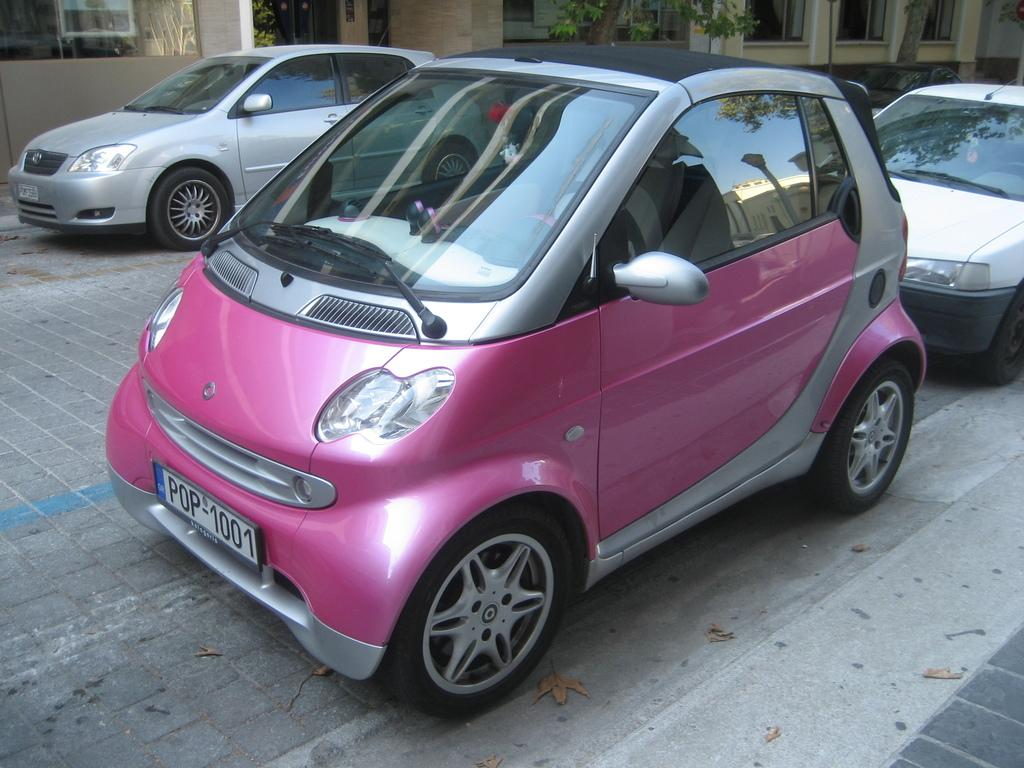How many cars are parked on the land in the image? There are three cars parked on the land in the image. What can be seen behind the cars? There is a complex behind the cars. What feature is prominent on the complex? The complex has plenty of windows. What type of vegetation is in front of the complex? There are two trees in front of the complex. What type of rice is being cooked in the image? There is no rice present in the image; it features three cars parked on the land, a complex behind them, and two trees in front. How many keys are needed to unlock the complex in the image? There is no information about keys or unlocking the complex in the image. 